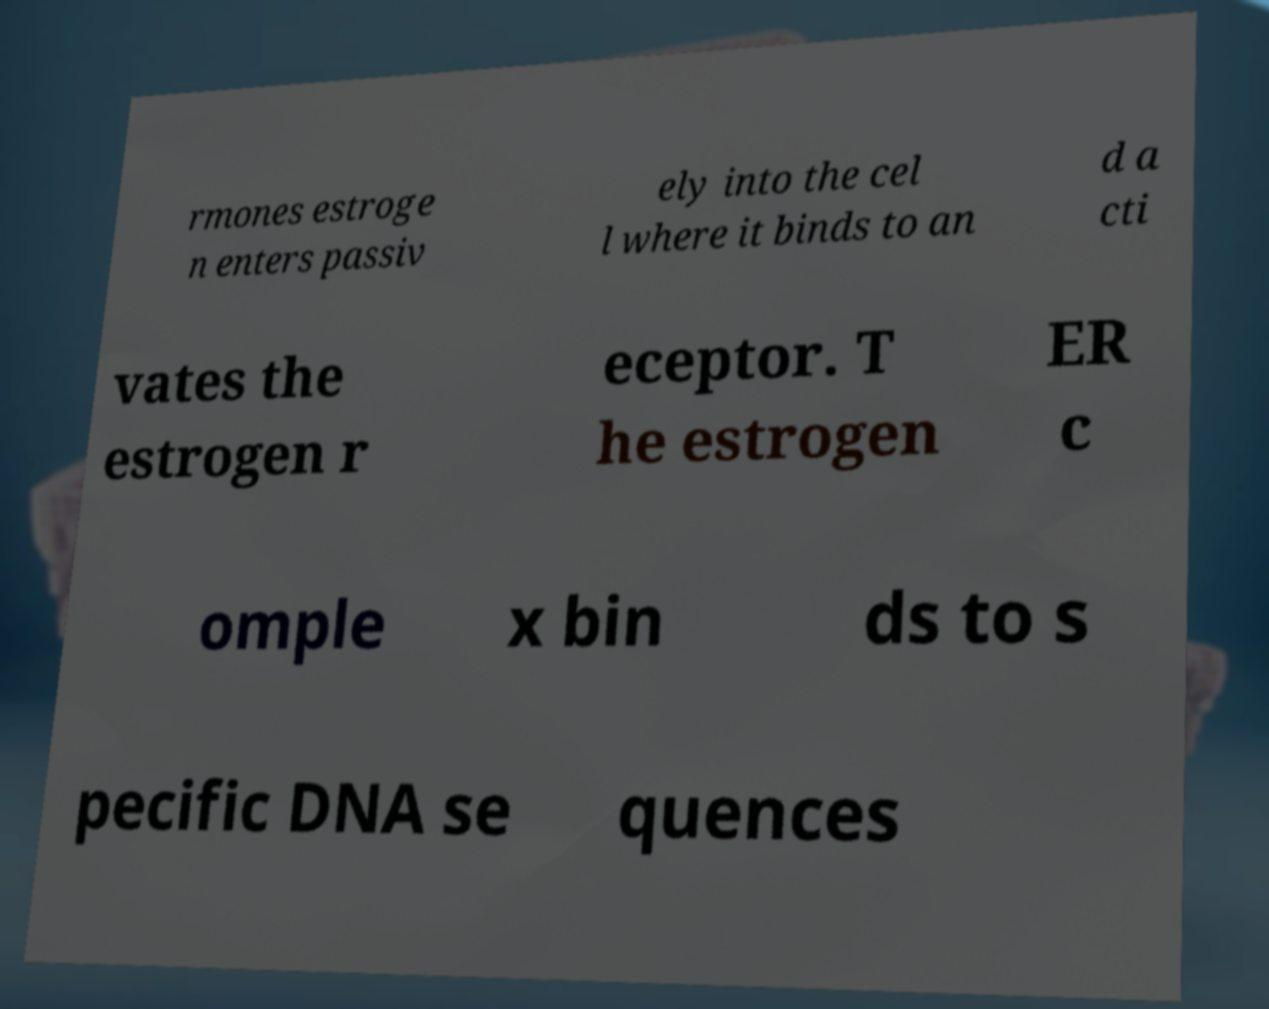For documentation purposes, I need the text within this image transcribed. Could you provide that? rmones estroge n enters passiv ely into the cel l where it binds to an d a cti vates the estrogen r eceptor. T he estrogen ER c omple x bin ds to s pecific DNA se quences 